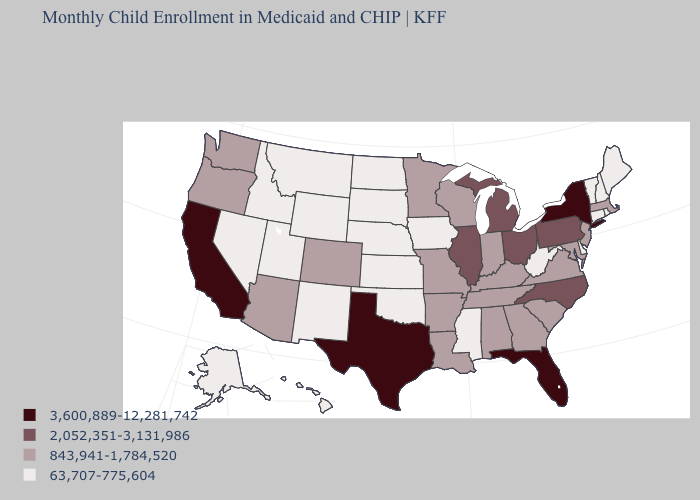Which states have the lowest value in the South?
Answer briefly. Delaware, Mississippi, Oklahoma, West Virginia. Among the states that border Minnesota , which have the lowest value?
Quick response, please. Iowa, North Dakota, South Dakota. Among the states that border Arizona , does New Mexico have the lowest value?
Quick response, please. Yes. Among the states that border South Dakota , does North Dakota have the lowest value?
Short answer required. Yes. Name the states that have a value in the range 843,941-1,784,520?
Answer briefly. Alabama, Arizona, Arkansas, Colorado, Georgia, Indiana, Kentucky, Louisiana, Maryland, Massachusetts, Minnesota, Missouri, New Jersey, Oregon, South Carolina, Tennessee, Virginia, Washington, Wisconsin. What is the value of Florida?
Quick response, please. 3,600,889-12,281,742. What is the lowest value in the MidWest?
Write a very short answer. 63,707-775,604. What is the highest value in the Northeast ?
Give a very brief answer. 3,600,889-12,281,742. Name the states that have a value in the range 3,600,889-12,281,742?
Be succinct. California, Florida, New York, Texas. Name the states that have a value in the range 2,052,351-3,131,986?
Be succinct. Illinois, Michigan, North Carolina, Ohio, Pennsylvania. What is the value of North Dakota?
Short answer required. 63,707-775,604. Does Alaska have the same value as Kansas?
Short answer required. Yes. What is the value of Illinois?
Quick response, please. 2,052,351-3,131,986. Among the states that border Delaware , does Pennsylvania have the highest value?
Concise answer only. Yes. What is the value of Georgia?
Keep it brief. 843,941-1,784,520. 